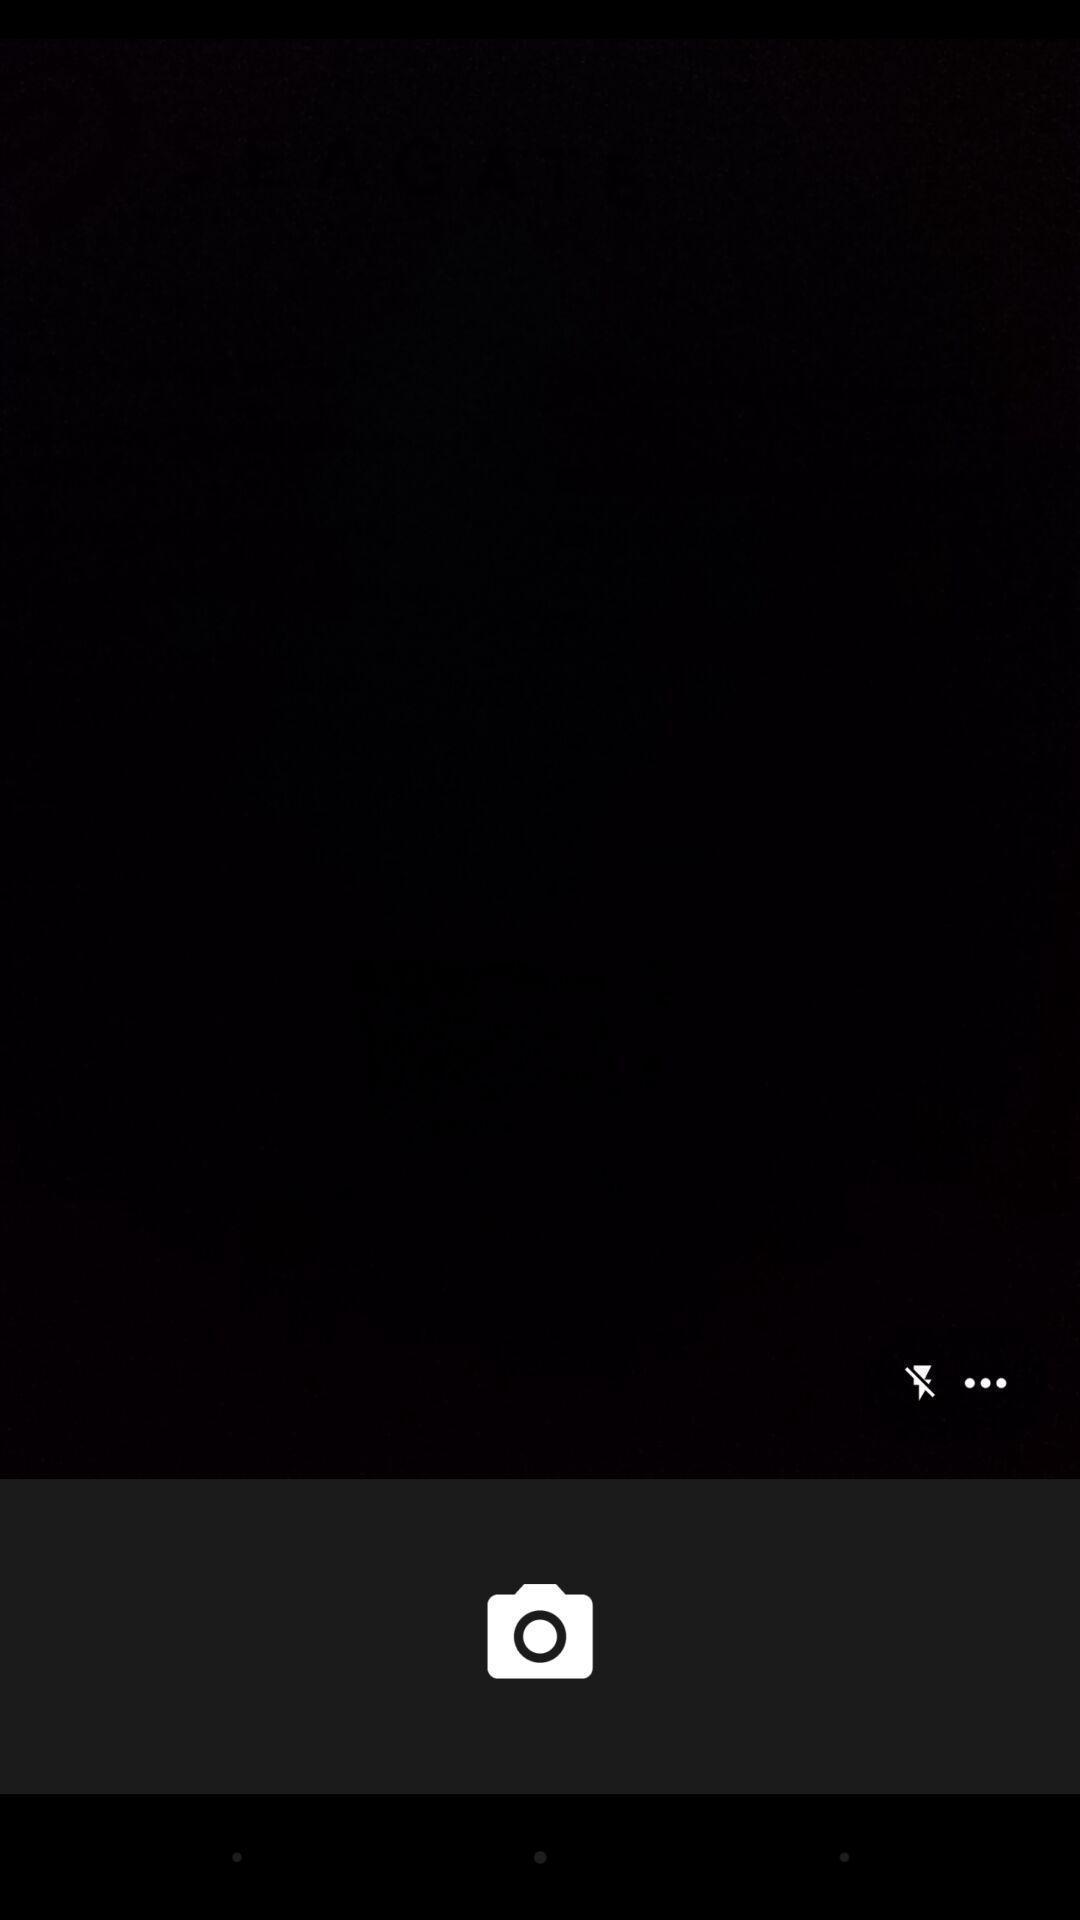Summarize the information in this screenshot. Page displaying the camera options and flash options. 